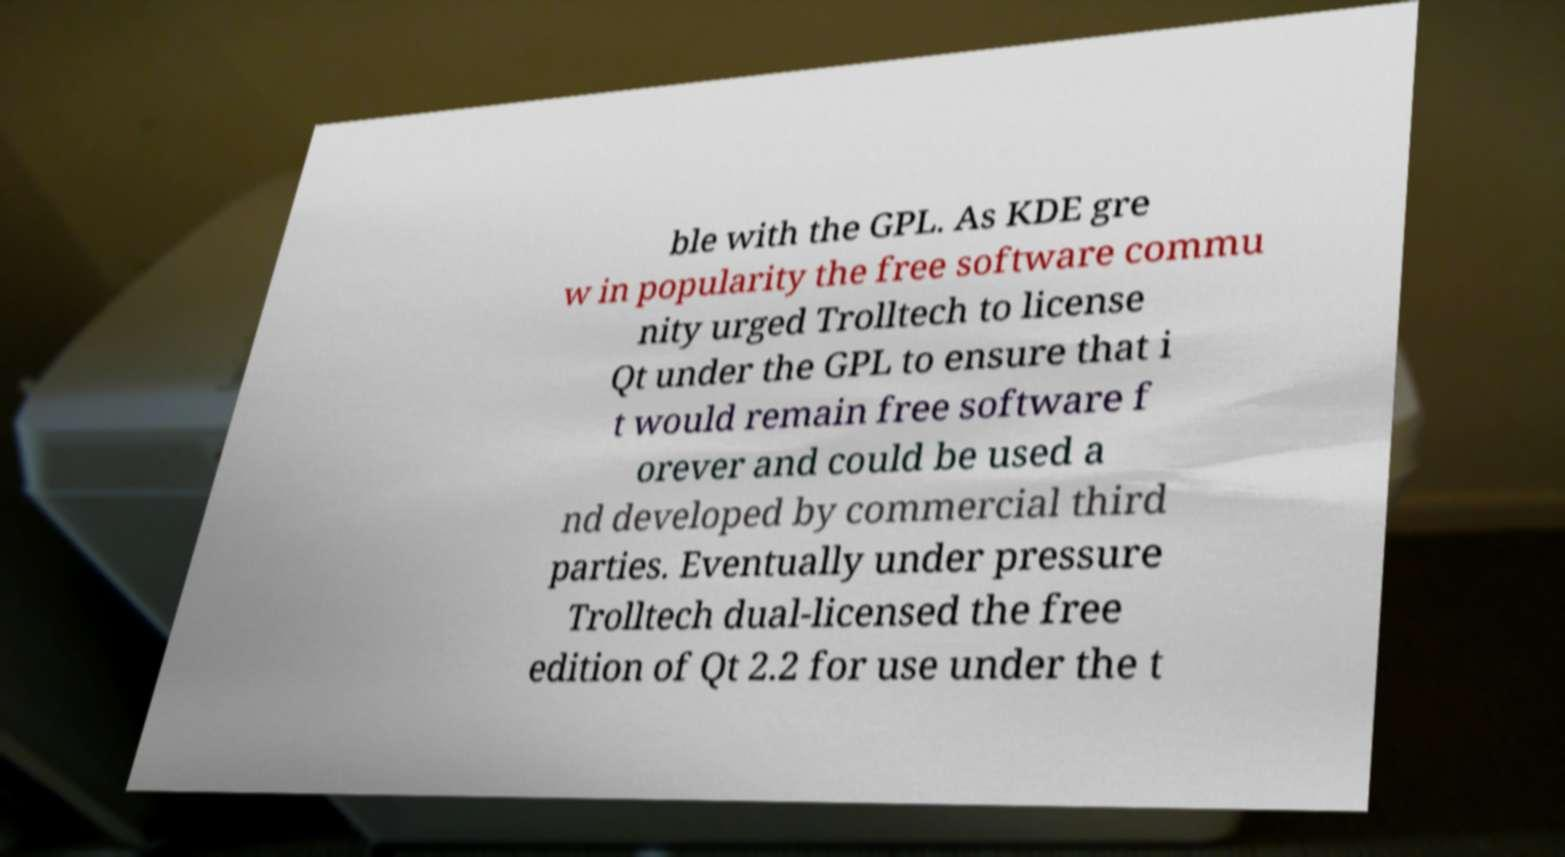There's text embedded in this image that I need extracted. Can you transcribe it verbatim? ble with the GPL. As KDE gre w in popularity the free software commu nity urged Trolltech to license Qt under the GPL to ensure that i t would remain free software f orever and could be used a nd developed by commercial third parties. Eventually under pressure Trolltech dual-licensed the free edition of Qt 2.2 for use under the t 